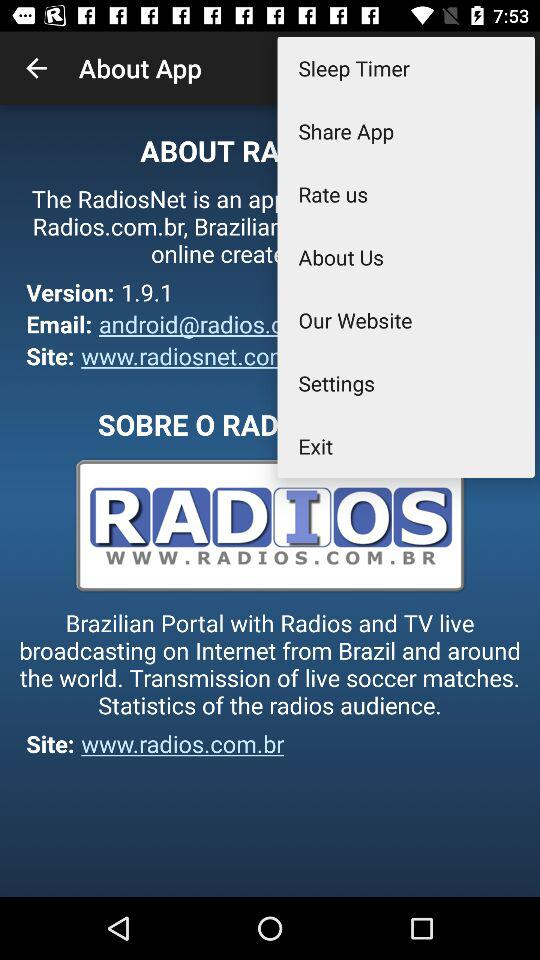What is the version? The version is 1.9.1. 